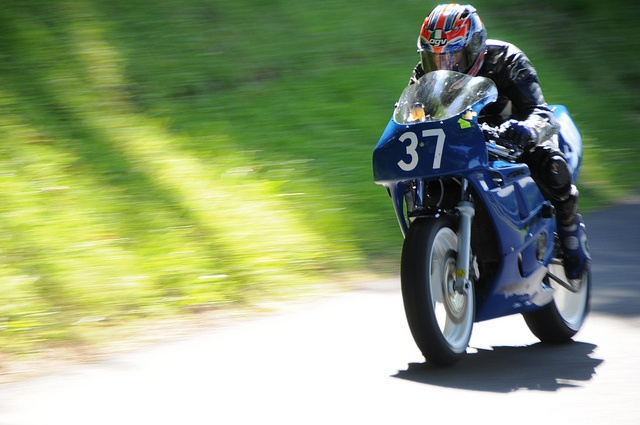Describe the objects in this image and their specific colors. I can see motorcycle in darkgreen, black, navy, darkgray, and gray tones and people in darkgreen, black, gray, white, and navy tones in this image. 